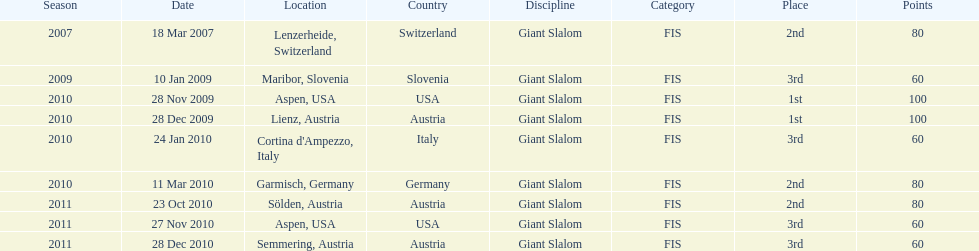What is the only location in the us? Aspen. 